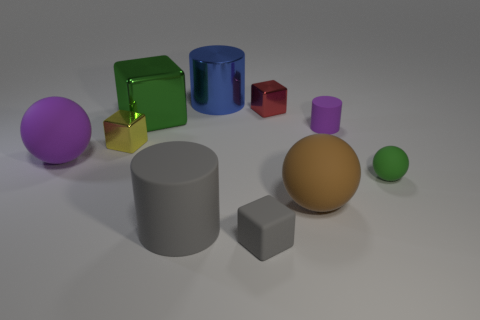Is there a big purple thing that has the same material as the small red cube?
Your answer should be compact. No. What material is the large blue cylinder?
Make the answer very short. Metal. There is a large object that is to the left of the green object behind the yellow object to the left of the tiny green ball; what shape is it?
Your answer should be very brief. Sphere. Is the number of gray objects that are behind the tiny purple cylinder greater than the number of large cyan metal cubes?
Offer a very short reply. No. There is a large blue shiny object; is its shape the same as the rubber thing that is in front of the gray cylinder?
Your response must be concise. No. There is a large object that is the same color as the tiny rubber cylinder; what is its shape?
Ensure brevity in your answer.  Sphere. There is a big gray cylinder that is behind the object in front of the big gray cylinder; what number of big blocks are behind it?
Ensure brevity in your answer.  1. There is a rubber block that is the same size as the green sphere; what color is it?
Keep it short and to the point. Gray. There is a cylinder that is in front of the purple matte object that is on the left side of the big brown sphere; what size is it?
Your answer should be very brief. Large. What size is the cylinder that is the same color as the rubber cube?
Give a very brief answer. Large. 